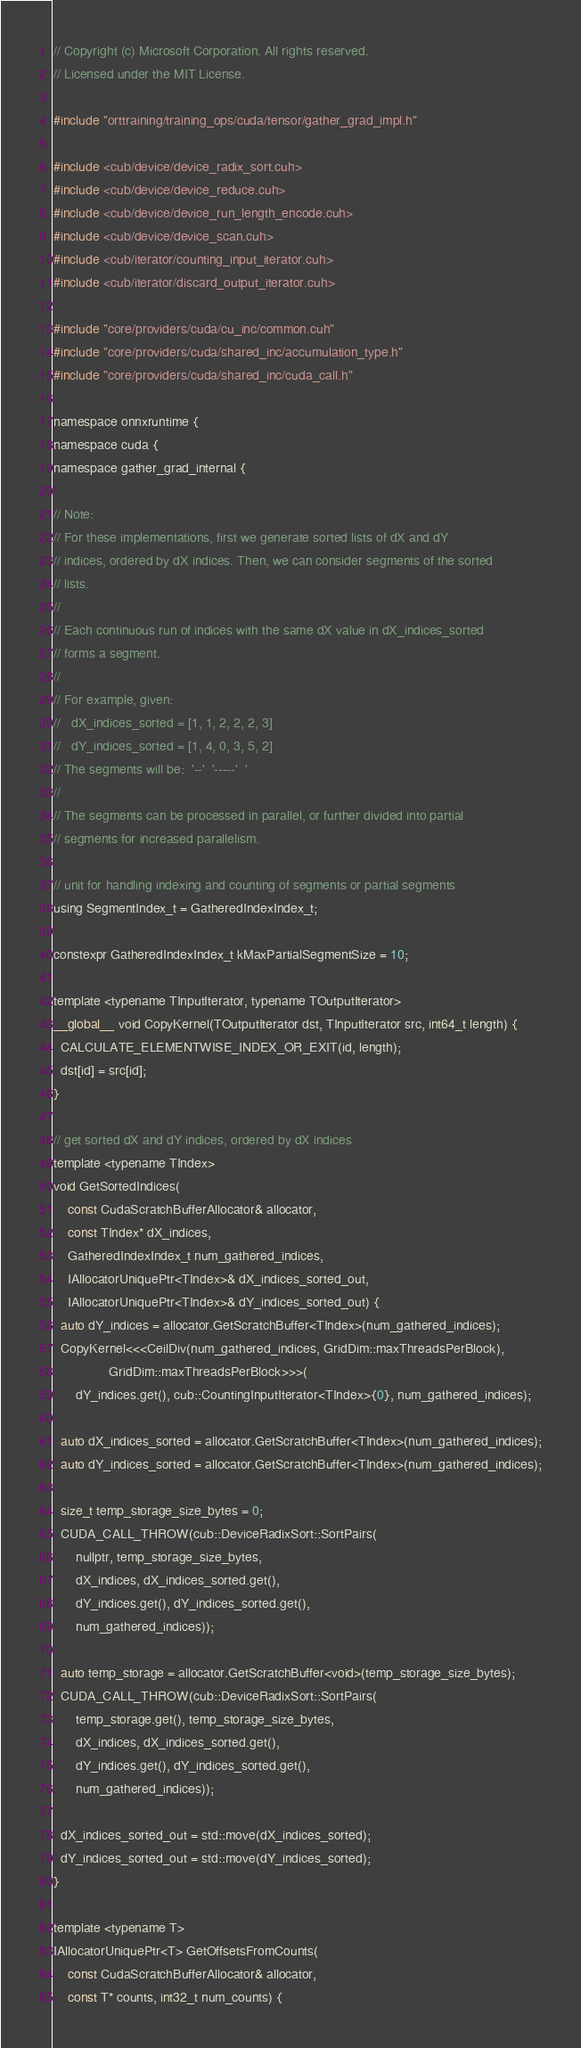<code> <loc_0><loc_0><loc_500><loc_500><_Cuda_>// Copyright (c) Microsoft Corporation. All rights reserved.
// Licensed under the MIT License.

#include "orttraining/training_ops/cuda/tensor/gather_grad_impl.h"

#include <cub/device/device_radix_sort.cuh>
#include <cub/device/device_reduce.cuh>
#include <cub/device/device_run_length_encode.cuh>
#include <cub/device/device_scan.cuh>
#include <cub/iterator/counting_input_iterator.cuh>
#include <cub/iterator/discard_output_iterator.cuh>

#include "core/providers/cuda/cu_inc/common.cuh"
#include "core/providers/cuda/shared_inc/accumulation_type.h"
#include "core/providers/cuda/shared_inc/cuda_call.h"

namespace onnxruntime {
namespace cuda {
namespace gather_grad_internal {

// Note:
// For these implementations, first we generate sorted lists of dX and dY
// indices, ordered by dX indices. Then, we can consider segments of the sorted
// lists.
//
// Each continuous run of indices with the same dX value in dX_indices_sorted
// forms a segment.
//
// For example, given:
//   dX_indices_sorted = [1, 1, 2, 2, 2, 3]
//   dY_indices_sorted = [1, 4, 0, 3, 5, 2]
// The segments will be:  '--'  '-----'  '
//
// The segments can be processed in parallel, or further divided into partial
// segments for increased parallelism.

// unit for handling indexing and counting of segments or partial segments
using SegmentIndex_t = GatheredIndexIndex_t;

constexpr GatheredIndexIndex_t kMaxPartialSegmentSize = 10;

template <typename TInputIterator, typename TOutputIterator>
__global__ void CopyKernel(TOutputIterator dst, TInputIterator src, int64_t length) {
  CALCULATE_ELEMENTWISE_INDEX_OR_EXIT(id, length);
  dst[id] = src[id];
}

// get sorted dX and dY indices, ordered by dX indices
template <typename TIndex>
void GetSortedIndices(
    const CudaScratchBufferAllocator& allocator,
    const TIndex* dX_indices,
    GatheredIndexIndex_t num_gathered_indices,
    IAllocatorUniquePtr<TIndex>& dX_indices_sorted_out,
    IAllocatorUniquePtr<TIndex>& dY_indices_sorted_out) {
  auto dY_indices = allocator.GetScratchBuffer<TIndex>(num_gathered_indices);
  CopyKernel<<<CeilDiv(num_gathered_indices, GridDim::maxThreadsPerBlock),
               GridDim::maxThreadsPerBlock>>>(
      dY_indices.get(), cub::CountingInputIterator<TIndex>{0}, num_gathered_indices);

  auto dX_indices_sorted = allocator.GetScratchBuffer<TIndex>(num_gathered_indices);
  auto dY_indices_sorted = allocator.GetScratchBuffer<TIndex>(num_gathered_indices);

  size_t temp_storage_size_bytes = 0;
  CUDA_CALL_THROW(cub::DeviceRadixSort::SortPairs(
      nullptr, temp_storage_size_bytes,
      dX_indices, dX_indices_sorted.get(),
      dY_indices.get(), dY_indices_sorted.get(),
      num_gathered_indices));

  auto temp_storage = allocator.GetScratchBuffer<void>(temp_storage_size_bytes);
  CUDA_CALL_THROW(cub::DeviceRadixSort::SortPairs(
      temp_storage.get(), temp_storage_size_bytes,
      dX_indices, dX_indices_sorted.get(),
      dY_indices.get(), dY_indices_sorted.get(),
      num_gathered_indices));

  dX_indices_sorted_out = std::move(dX_indices_sorted);
  dY_indices_sorted_out = std::move(dY_indices_sorted);
}

template <typename T>
IAllocatorUniquePtr<T> GetOffsetsFromCounts(
    const CudaScratchBufferAllocator& allocator,
    const T* counts, int32_t num_counts) {</code> 